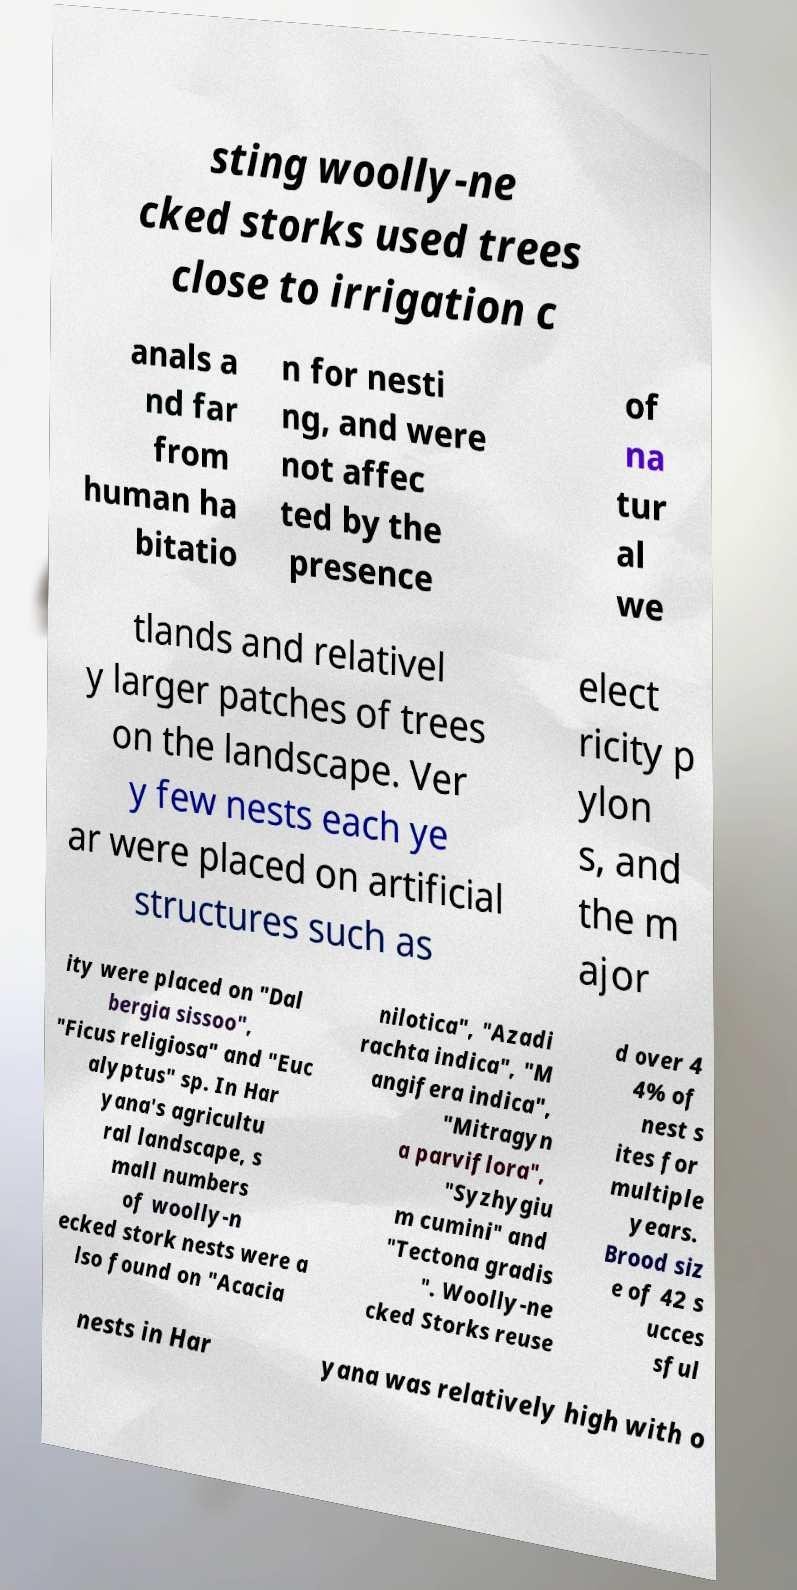Could you assist in decoding the text presented in this image and type it out clearly? sting woolly-ne cked storks used trees close to irrigation c anals a nd far from human ha bitatio n for nesti ng, and were not affec ted by the presence of na tur al we tlands and relativel y larger patches of trees on the landscape. Ver y few nests each ye ar were placed on artificial structures such as elect ricity p ylon s, and the m ajor ity were placed on "Dal bergia sissoo", "Ficus religiosa" and "Euc alyptus" sp. In Har yana's agricultu ral landscape, s mall numbers of woolly-n ecked stork nests were a lso found on "Acacia nilotica", "Azadi rachta indica", "M angifera indica", "Mitragyn a parviflora", "Syzhygiu m cumini" and "Tectona gradis ". Woolly-ne cked Storks reuse d over 4 4% of nest s ites for multiple years. Brood siz e of 42 s ucces sful nests in Har yana was relatively high with o 